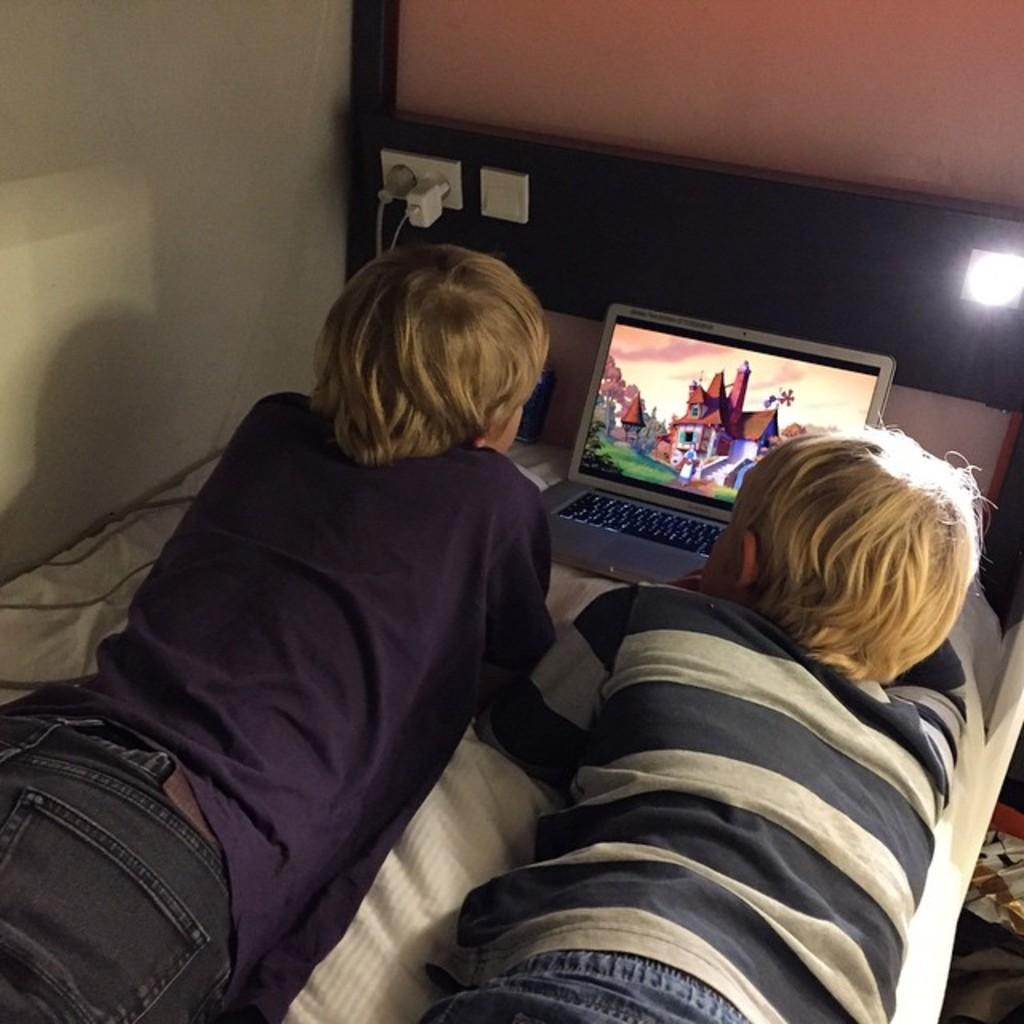How many people are lying on the bed in the image? There are two people lying on the bed in the image. What object is in front of the people on the bed? There is a laptop in front of the people. What is providing light in the image? There is a light in front of the people. What is used to power the laptop and light in the image? There is a socket and plugs in front of the people. What can be seen in the background of the image? There is a wall in the background. How many cats are sitting on the faucet in the image? There are no cats or faucets present in the image. What sound can be heard coming from the whistle in the image? There is no whistle present in the image. 